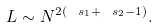<formula> <loc_0><loc_0><loc_500><loc_500>L \sim N ^ { 2 ( \ s _ { 1 } + \ s _ { 2 } - 1 ) } .</formula> 